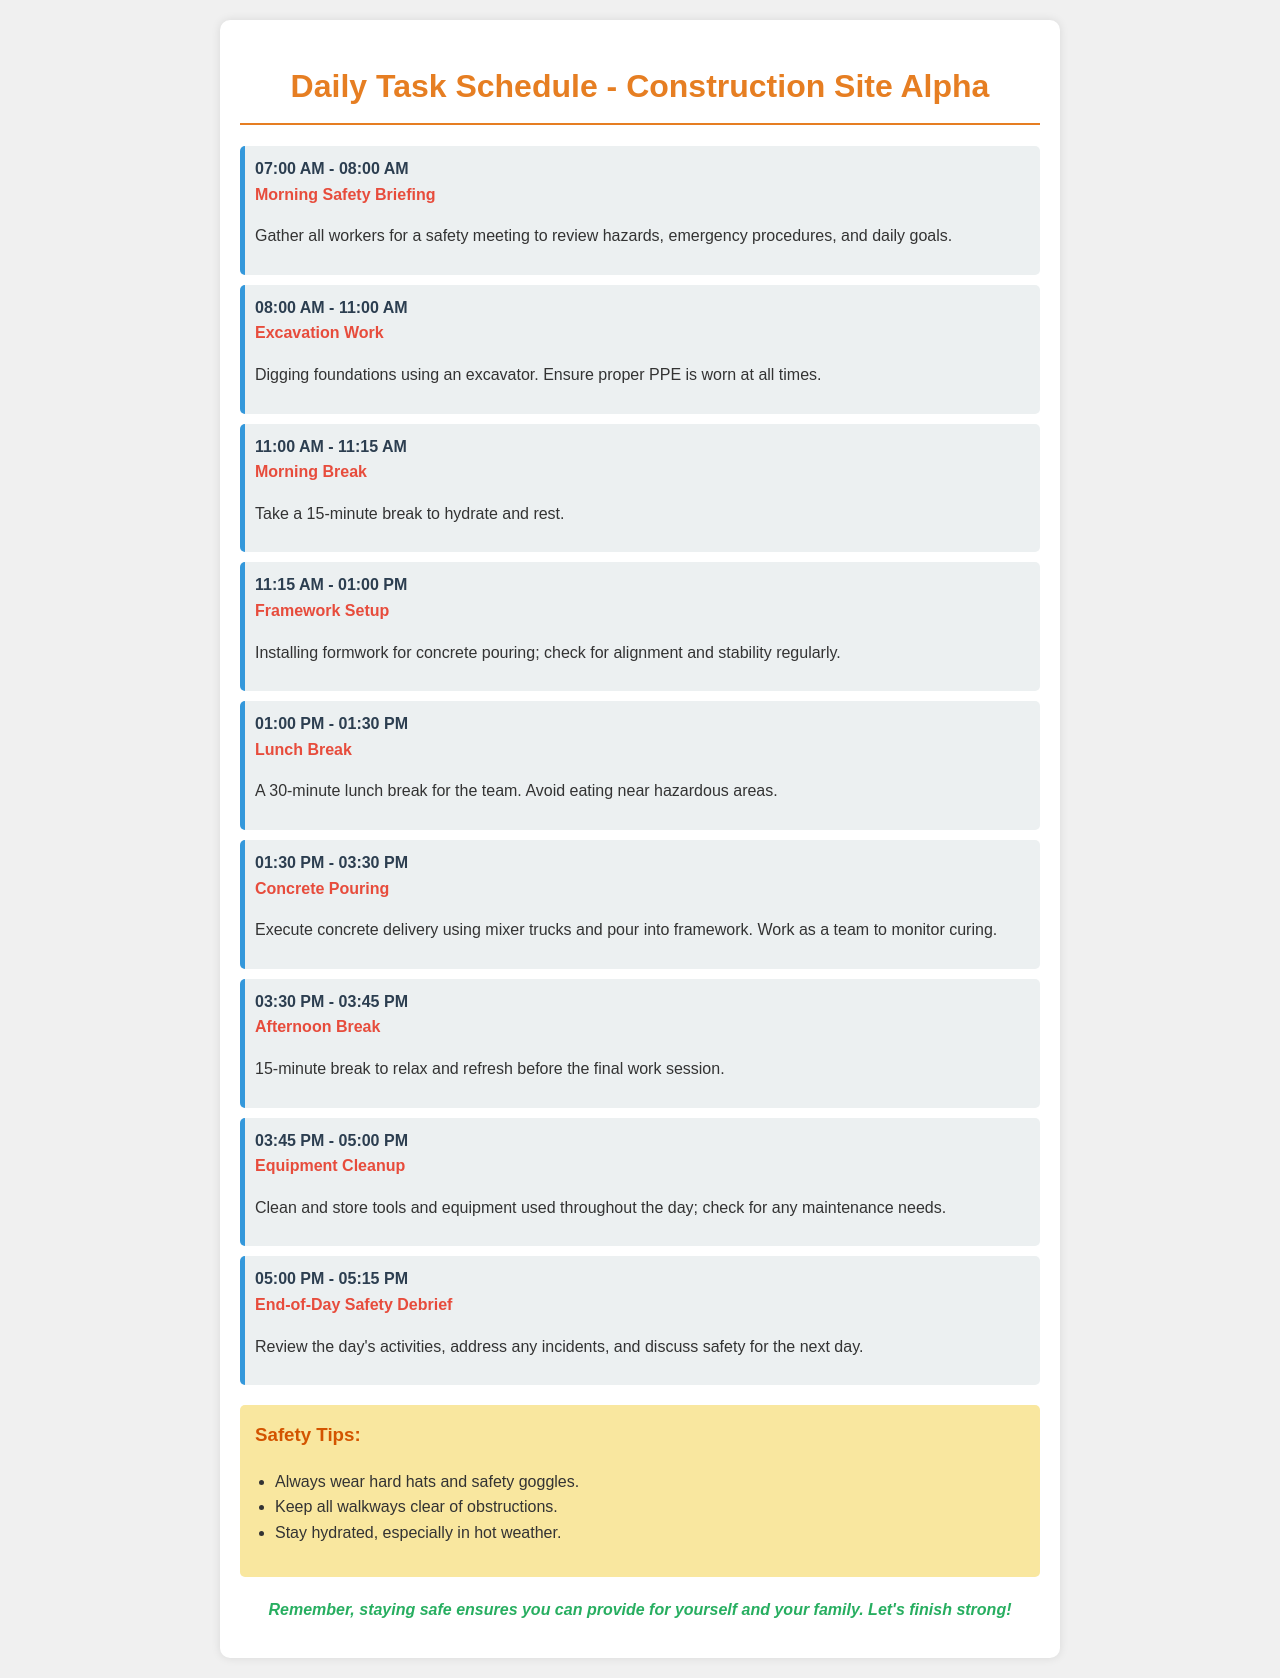What time does the morning safety briefing start? The morning safety briefing starts at 07:00 AM as indicated in the schedule.
Answer: 07:00 AM How long is the morning break? The morning break lasts for 15 minutes, as specified in the document.
Answer: 15 minutes What activity is scheduled from 01:30 PM to 03:30 PM? The activity scheduled during this time is concrete pouring, as stated in the schedule.
Answer: Concrete pouring What should workers do during the lunch break? Workers are advised to avoid eating near hazardous areas during the lunch break, according to the notes.
Answer: Avoid eating near hazardous areas What is the purpose of the end-of-day safety debrief? The end-of-day safety debrief is to review the day's activities and discuss safety for the next day.
Answer: Review the day's activities What type of equipment activity occurs after the afternoon break? The activity after the afternoon break is equipment cleanup, as listed in the schedule.
Answer: Equipment cleanup How many total breaks are scheduled throughout the day? There are three breaks scheduled: one morning break, one lunch break, and one afternoon break.
Answer: Three breaks What color is used for the task activities in the schedule? The color used for task activities in the schedule is red, as represented in the document.
Answer: Red 